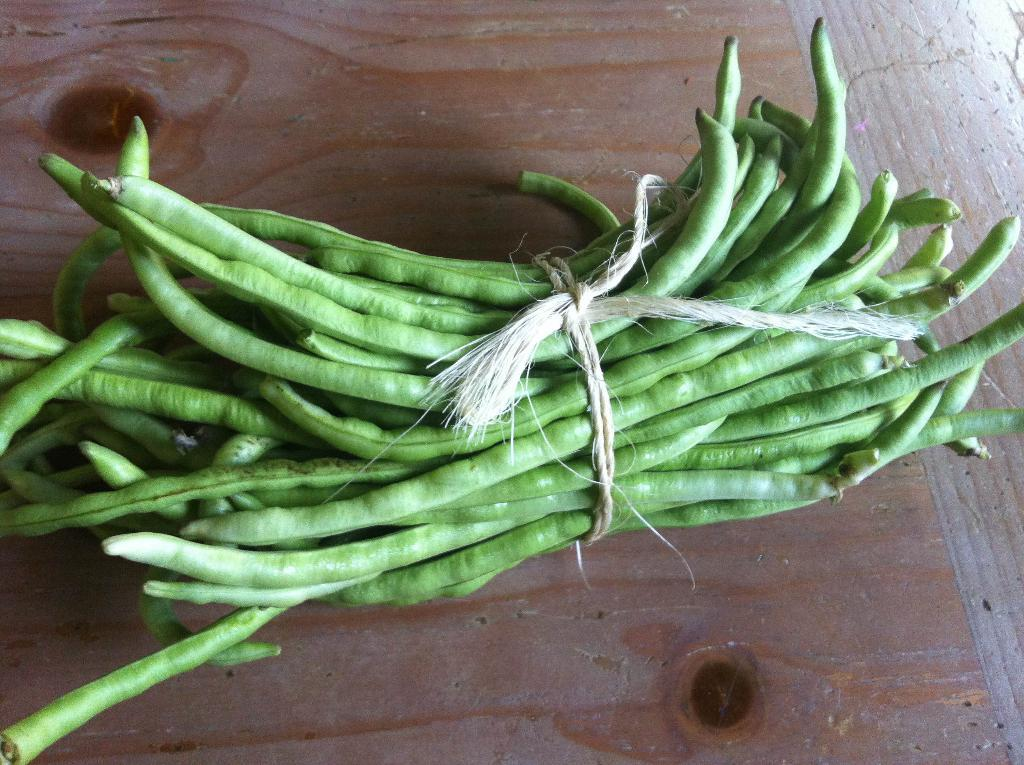What is the main subject of the image? The main subject of the image is beans. How are the beans arranged or connected in the image? The beans are tied together with a rope in the image. Where are the beans placed in the image? The beans are kept on a table in the image. What type of curtain can be seen hanging from the slope in the image? There is no curtain or slope present in the image; it features beans tied together with a rope on a table. 